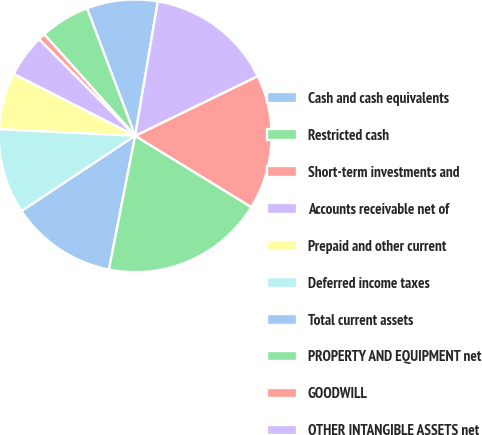Convert chart. <chart><loc_0><loc_0><loc_500><loc_500><pie_chart><fcel>Cash and cash equivalents<fcel>Restricted cash<fcel>Short-term investments and<fcel>Accounts receivable net of<fcel>Prepaid and other current<fcel>Deferred income taxes<fcel>Total current assets<fcel>PROPERTY AND EQUIPMENT net<fcel>GOODWILL<fcel>OTHER INTANGIBLE ASSETS net<nl><fcel>8.4%<fcel>5.88%<fcel>0.84%<fcel>5.04%<fcel>6.72%<fcel>10.08%<fcel>12.6%<fcel>19.33%<fcel>15.97%<fcel>15.13%<nl></chart> 